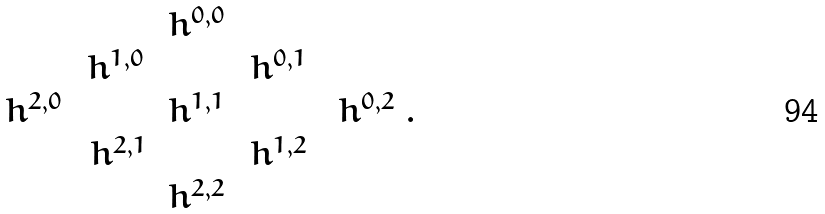<formula> <loc_0><loc_0><loc_500><loc_500>\begin{array} { c c c c c } & & h ^ { 0 , 0 } & & \\ & h ^ { 1 , 0 } \, & & \, h ^ { 0 , 1 } \, & \\ h ^ { 2 , 0 } \, & \, & h ^ { 1 , 1 } & \, & \, h ^ { 0 , 2 } \\ & h ^ { 2 , 1 } & & h ^ { 1 , 2 } & \\ & & h ^ { 2 , 2 } & & \end{array} .</formula> 